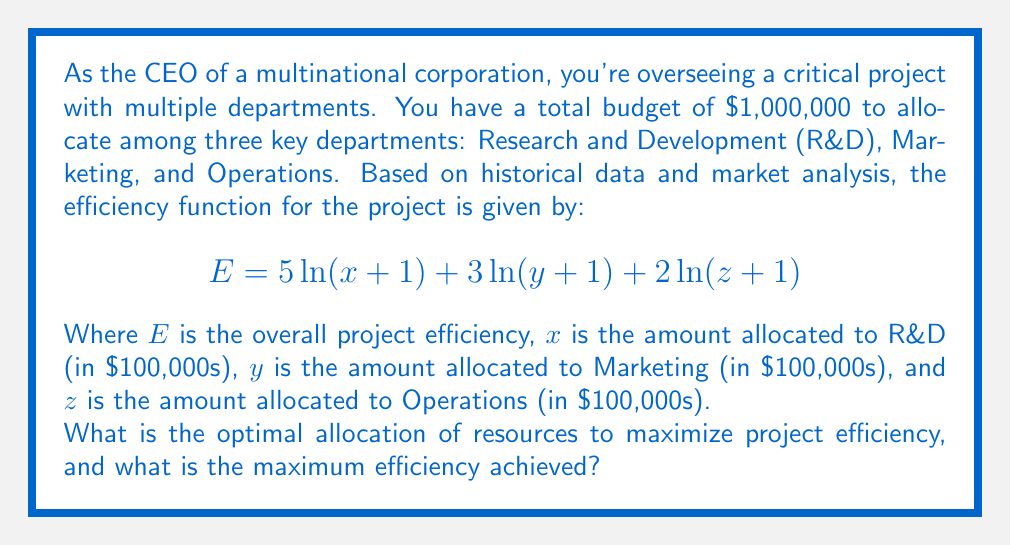Teach me how to tackle this problem. To solve this optimization problem, we'll use the method of Lagrange multipliers:

1) First, we set up the Lagrangian function:
   $$L = 5\ln(x+1) + 3\ln(y+1) + 2\ln(z+1) - \lambda(x + y + z - 10)$$
   Note that we use 10 instead of 1,000,000 because our variables are in $100,000s.

2) Now, we take partial derivatives and set them equal to zero:
   $$\frac{\partial L}{\partial x} = \frac{5}{x+1} - \lambda = 0$$
   $$\frac{\partial L}{\partial y} = \frac{3}{y+1} - \lambda = 0$$
   $$\frac{\partial L}{\partial z} = \frac{2}{z+1} - \lambda = 0$$
   $$\frac{\partial L}{\partial \lambda} = x + y + z - 10 = 0$$

3) From these equations, we can deduce:
   $$\frac{5}{x+1} = \frac{3}{y+1} = \frac{2}{z+1} = \lambda$$

4) Let's define $k = \frac{1}{\lambda}$. Then:
   $$x+1 = 5k$$
   $$y+1 = 3k$$
   $$z+1 = 2k$$

5) Substituting these into the constraint equation:
   $$(5k-1) + (3k-1) + (2k-1) = 10$$
   $$10k - 3 = 10$$
   $$10k = 13$$
   $$k = 1.3$$

6) Now we can solve for x, y, and z:
   $$x = 5k - 1 = 5(1.3) - 1 = 5.5$$
   $$y = 3k - 1 = 3(1.3) - 1 = 2.9$$
   $$z = 2k - 1 = 2(1.3) - 1 = 1.6$$

7) The maximum efficiency is:
   $$E = 5\ln(5.5+1) + 3\ln(2.9+1) + 2\ln(1.6+1) \approx 13.459$$

Therefore, the optimal allocation is:
R&D: $550,000
Marketing: $290,000
Operations: $160,000
Answer: Optimal allocation:
R&D: $550,000
Marketing: $290,000
Operations: $160,000

Maximum efficiency achieved: 13.459 